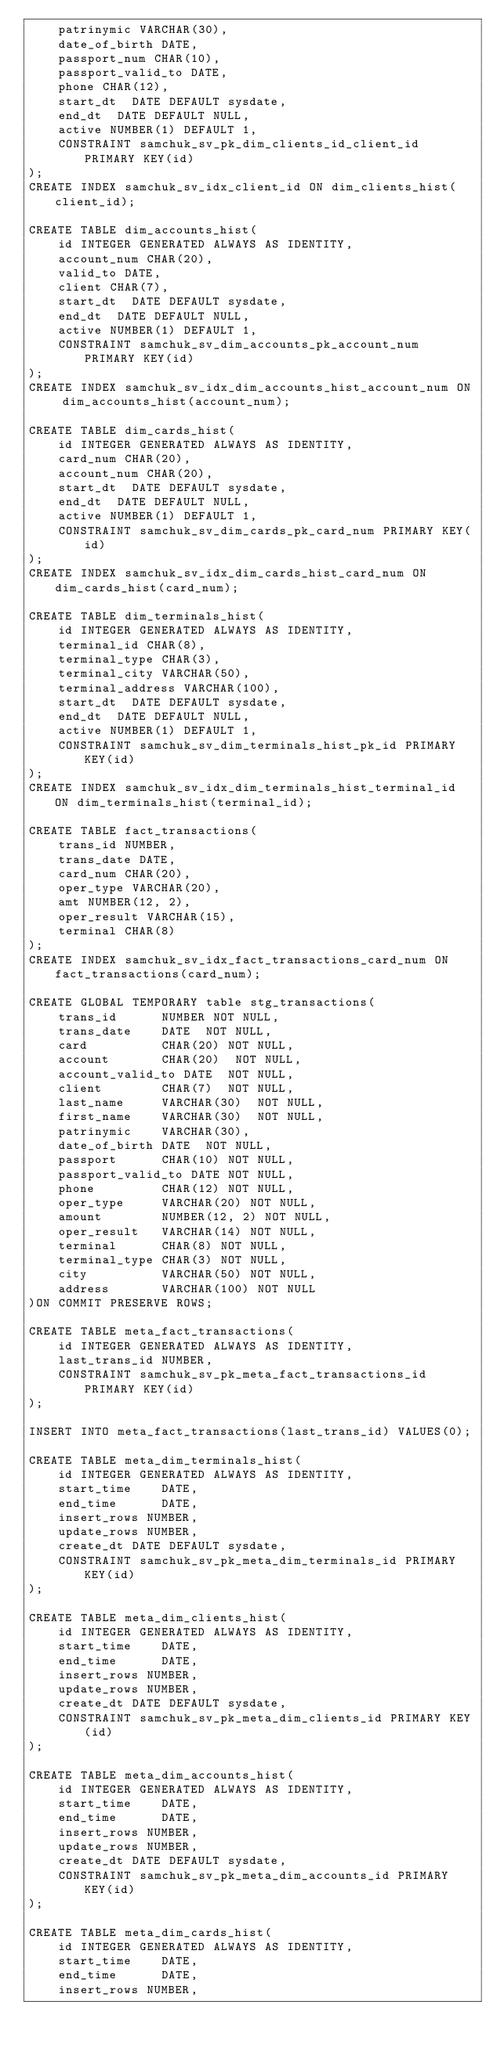Convert code to text. <code><loc_0><loc_0><loc_500><loc_500><_SQL_>    patrinymic VARCHAR(30),
    date_of_birth DATE,
    passport_num CHAR(10),
    passport_valid_to DATE,
    phone CHAR(12),
    start_dt  DATE DEFAULT sysdate,
    end_dt  DATE DEFAULT NULL,
    active NUMBER(1) DEFAULT 1,
    CONSTRAINT samchuk_sv_pk_dim_clients_id_client_id PRIMARY KEY(id)
);
CREATE INDEX samchuk_sv_idx_client_id ON dim_clients_hist(client_id);

CREATE TABLE dim_accounts_hist(
    id INTEGER GENERATED ALWAYS AS IDENTITY,
    account_num CHAR(20),
    valid_to DATE,
    client CHAR(7),
    start_dt  DATE DEFAULT sysdate,
    end_dt  DATE DEFAULT NULL,
    active NUMBER(1) DEFAULT 1,
    CONSTRAINT samchuk_sv_dim_accounts_pk_account_num PRIMARY KEY(id)
);
CREATE INDEX samchuk_sv_idx_dim_accounts_hist_account_num ON dim_accounts_hist(account_num);

CREATE TABLE dim_cards_hist(
    id INTEGER GENERATED ALWAYS AS IDENTITY,
    card_num CHAR(20),
    account_num CHAR(20),
    start_dt  DATE DEFAULT sysdate,
    end_dt  DATE DEFAULT NULL,
    active NUMBER(1) DEFAULT 1,
    CONSTRAINT samchuk_sv_dim_cards_pk_card_num PRIMARY KEY(id)
);
CREATE INDEX samchuk_sv_idx_dim_cards_hist_card_num ON dim_cards_hist(card_num);

CREATE TABLE dim_terminals_hist(
    id INTEGER GENERATED ALWAYS AS IDENTITY,
    terminal_id CHAR(8),
    terminal_type CHAR(3),
    terminal_city VARCHAR(50),
    terminal_address VARCHAR(100),
    start_dt  DATE DEFAULT sysdate,
    end_dt  DATE DEFAULT NULL,
    active NUMBER(1) DEFAULT 1,
    CONSTRAINT samchuk_sv_dim_terminals_hist_pk_id PRIMARY KEY(id)
);
CREATE INDEX samchuk_sv_idx_dim_terminals_hist_terminal_id ON dim_terminals_hist(terminal_id);

CREATE TABLE fact_transactions(
    trans_id NUMBER,
    trans_date DATE,
    card_num CHAR(20),
    oper_type VARCHAR(20),
    amt NUMBER(12, 2),
    oper_result VARCHAR(15),
    terminal CHAR(8)
);
CREATE INDEX samchuk_sv_idx_fact_transactions_card_num ON fact_transactions(card_num);

CREATE GLOBAL TEMPORARY table stg_transactions(
    trans_id      NUMBER NOT NULL,
    trans_date    DATE  NOT NULL,
    card          CHAR(20) NOT NULL,
    account       CHAR(20)  NOT NULL,
    account_valid_to DATE  NOT NULL,
    client        CHAR(7)  NOT NULL,
    last_name     VARCHAR(30)  NOT NULL,
    first_name    VARCHAR(30)  NOT NULL,
    patrinymic    VARCHAR(30),
    date_of_birth DATE  NOT NULL,
    passport      CHAR(10) NOT NULL,
    passport_valid_to DATE NOT NULL,
    phone         CHAR(12) NOT NULL,
    oper_type     VARCHAR(20) NOT NULL,
    amount        NUMBER(12, 2) NOT NULL,
    oper_result   VARCHAR(14) NOT NULL,
    terminal      CHAR(8) NOT NULL,
    terminal_type CHAR(3) NOT NULL,
    city          VARCHAR(50) NOT NULL,
    address       VARCHAR(100) NOT NULL
)ON COMMIT PRESERVE ROWS;

CREATE TABLE meta_fact_transactions(
    id INTEGER GENERATED ALWAYS AS IDENTITY,
    last_trans_id NUMBER,
	CONSTRAINT samchuk_sv_pk_meta_fact_transactions_id PRIMARY KEY(id)
);

INSERT INTO meta_fact_transactions(last_trans_id) VALUES(0);

CREATE TABLE meta_dim_terminals_hist(
    id INTEGER GENERATED ALWAYS AS IDENTITY,
    start_time    DATE,
    end_time      DATE,
    insert_rows NUMBER,
    update_rows NUMBER,
    create_dt DATE DEFAULT sysdate,
	CONSTRAINT samchuk_sv_pk_meta_dim_terminals_id PRIMARY KEY(id)
);

CREATE TABLE meta_dim_clients_hist(
    id INTEGER GENERATED ALWAYS AS IDENTITY,
    start_time    DATE,
    end_time      DATE,
    insert_rows NUMBER,
    update_rows NUMBER,
    create_dt DATE DEFAULT sysdate,
	CONSTRAINT samchuk_sv_pk_meta_dim_clients_id PRIMARY KEY(id)
);

CREATE TABLE meta_dim_accounts_hist(
    id INTEGER GENERATED ALWAYS AS IDENTITY,
    start_time    DATE,
    end_time      DATE,
    insert_rows NUMBER,
    update_rows NUMBER,
    create_dt DATE DEFAULT sysdate,
	CONSTRAINT samchuk_sv_pk_meta_dim_accounts_id PRIMARY KEY(id)
);

CREATE TABLE meta_dim_cards_hist(
    id INTEGER GENERATED ALWAYS AS IDENTITY,
    start_time    DATE,
    end_time      DATE,
    insert_rows NUMBER,</code> 